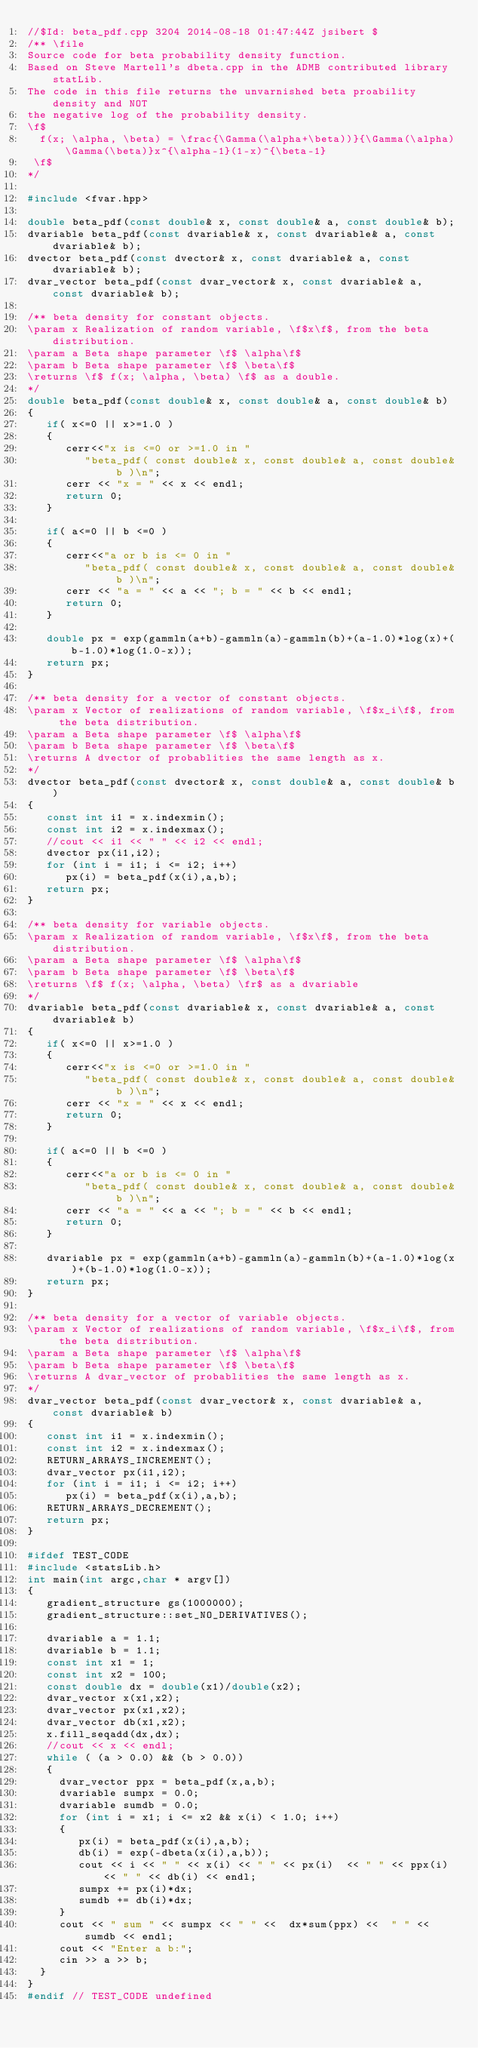Convert code to text. <code><loc_0><loc_0><loc_500><loc_500><_C++_>//$Id: beta_pdf.cpp 3204 2014-08-18 01:47:44Z jsibert $
/** \file
Source code for beta probability density function.
Based on Steve Martell's dbeta.cpp in the ADMB contributed library statLib.
The code in this file returns the unvarnished beta proability density and NOT
the negative log of the probability density.
\f$
 	f(x; \alpha, \beta) = \frac{\Gamma(\alpha+\beta))}{\Gamma(\alpha)\Gamma(\beta)}x^{\alpha-1}(1-x)^{\beta-1}
 \f$
*/

#include <fvar.hpp>

double beta_pdf(const double& x, const double& a, const double& b);
dvariable beta_pdf(const dvariable& x, const dvariable& a, const dvariable& b);
dvector beta_pdf(const dvector& x, const dvariable& a, const dvariable& b);
dvar_vector beta_pdf(const dvar_vector& x, const dvariable& a, const dvariable& b);

/** beta density for constant objects.
\param x Realization of random variable, \f$x\f$, from the beta distribution.
\param a Beta shape parameter \f$ \alpha\f$
\param b Beta shape parameter \f$ \beta\f$
\returns \f$ f(x; \alpha, \beta) \f$ as a double.
*/
double beta_pdf(const double& x, const double& a, const double& b)
{
   if( x<=0 || x>=1.0 )
   {
      cerr<<"x is <=0 or >=1.0 in "
         "beta_pdf( const double& x, const double& a, const double& b )\n";
      cerr << "x = " << x << endl;
      return 0;
   }
   
   if( a<=0 || b <=0 )
   {
      cerr<<"a or b is <= 0 in "
         "beta_pdf( const double& x, const double& a, const double& b )\n";
      cerr << "a = " << a << "; b = " << b << endl;
      return 0;
   }
   
   double px = exp(gammln(a+b)-gammln(a)-gammln(b)+(a-1.0)*log(x)+(b-1.0)*log(1.0-x));
   return px;
}

/** beta density for a vector of constant objects.
\param x Vector of realizations of random variable, \f$x_i\f$, from the beta distribution.
\param a Beta shape parameter \f$ \alpha\f$
\param b Beta shape parameter \f$ \beta\f$
\returns A dvector of probablities the same length as x.
*/
dvector beta_pdf(const dvector& x, const double& a, const double& b)
{
   const int i1 = x.indexmin();
   const int i2 = x.indexmax();
   //cout << i1 << " " << i2 << endl;
   dvector px(i1,i2);
   for (int i = i1; i <= i2; i++)
      px(i) = beta_pdf(x(i),a,b);
   return px;
}

/** beta density for variable objects.
\param x Realization of random variable, \f$x\f$, from the beta distribution.
\param a Beta shape parameter \f$ \alpha\f$
\param b Beta shape parameter \f$ \beta\f$
\returns \f$ f(x; \alpha, \beta) \fr$ as a dvariable
*/
dvariable beta_pdf(const dvariable& x, const dvariable& a, const dvariable& b)
{
   if( x<=0 || x>=1.0 )
   {
      cerr<<"x is <=0 or >=1.0 in "
         "beta_pdf( const double& x, const double& a, const double& b )\n";
      cerr << "x = " << x << endl;
      return 0;
   }
   
   if( a<=0 || b <=0 )
   {
      cerr<<"a or b is <= 0 in "
         "beta_pdf( const double& x, const double& a, const double& b )\n";
      cerr << "a = " << a << "; b = " << b << endl;
      return 0;
   }
   
   dvariable px = exp(gammln(a+b)-gammln(a)-gammln(b)+(a-1.0)*log(x)+(b-1.0)*log(1.0-x));
   return px;
}

/** beta density for a vector of variable objects.
\param x Vector of realizations of random variable, \f$x_i\f$, from the beta distribution.
\param a Beta shape parameter \f$ \alpha\f$
\param b Beta shape parameter \f$ \beta\f$
\returns A dvar_vector of probablities the same length as x.
*/
dvar_vector beta_pdf(const dvar_vector& x, const dvariable& a, const dvariable& b)
{
   const int i1 = x.indexmin();
   const int i2 = x.indexmax();
   RETURN_ARRAYS_INCREMENT();
   dvar_vector px(i1,i2);
   for (int i = i1; i <= i2; i++)
      px(i) = beta_pdf(x(i),a,b);
   RETURN_ARRAYS_DECREMENT();
   return px;
}

#ifdef TEST_CODE
#include <statsLib.h>
int main(int argc,char * argv[])
{
   gradient_structure gs(1000000);
   gradient_structure::set_NO_DERIVATIVES();

   dvariable a = 1.1;
   dvariable b = 1.1;
   const int x1 = 1;
   const int x2 = 100;
   const double dx = double(x1)/double(x2);
   dvar_vector x(x1,x2);
   dvar_vector px(x1,x2);
   dvar_vector db(x1,x2);
   x.fill_seqadd(dx,dx);
   //cout << x << endl;
   while ( (a > 0.0) && (b > 0.0))
   {
     dvar_vector ppx = beta_pdf(x,a,b);
     dvariable sumpx = 0.0;
     dvariable sumdb = 0.0;
     for (int i = x1; i <= x2 && x(i) < 1.0; i++)
     {
        px(i) = beta_pdf(x(i),a,b);
        db(i) = exp(-dbeta(x(i),a,b));
        cout << i << " " << x(i) << " " << px(i)  << " " << ppx(i) << " " << db(i) << endl;
        sumpx += px(i)*dx;
        sumdb += db(i)*dx;
     }
     cout << " sum " << sumpx << " " <<  dx*sum(ppx) <<  " " << sumdb << endl;
     cout << "Enter a b:";
     cin >> a >> b;
  }
}
#endif // TEST_CODE undefined
</code> 